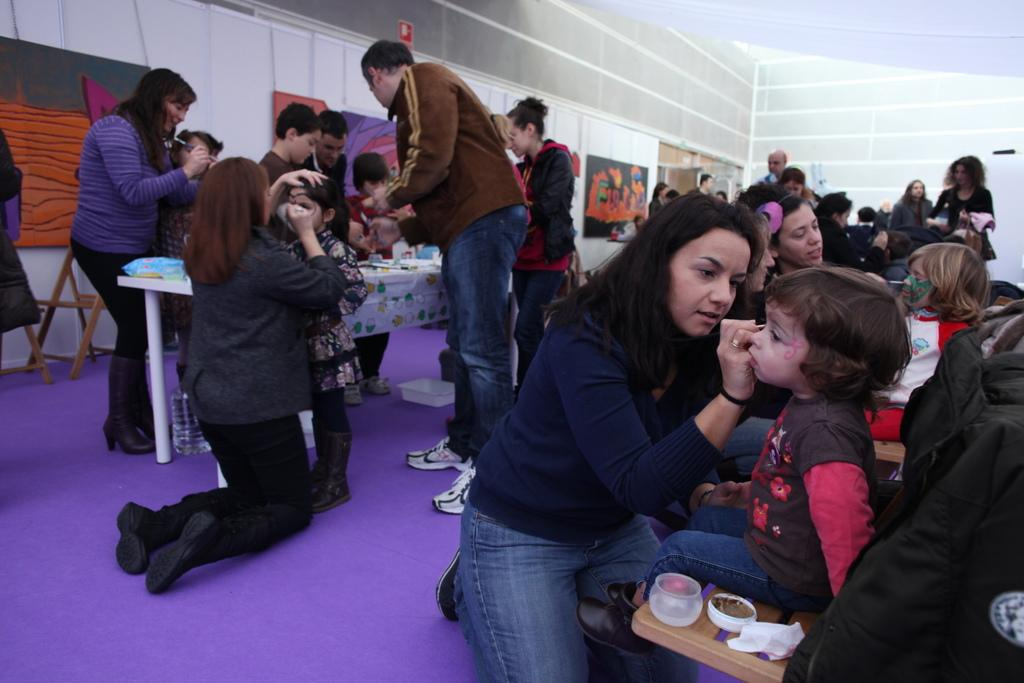Who are the people interacting with in the image? The people are reading to children in the image. What type of furniture is present in the image? There are tables and chairs in the image. What can be seen on the walls in the image? There are banners on the wall in the image. What else is visible in the image besides people and furniture? There are objects in the image. What type of wind can be seen blowing through the image? There is no wind present in the image; it is an indoor scene. 